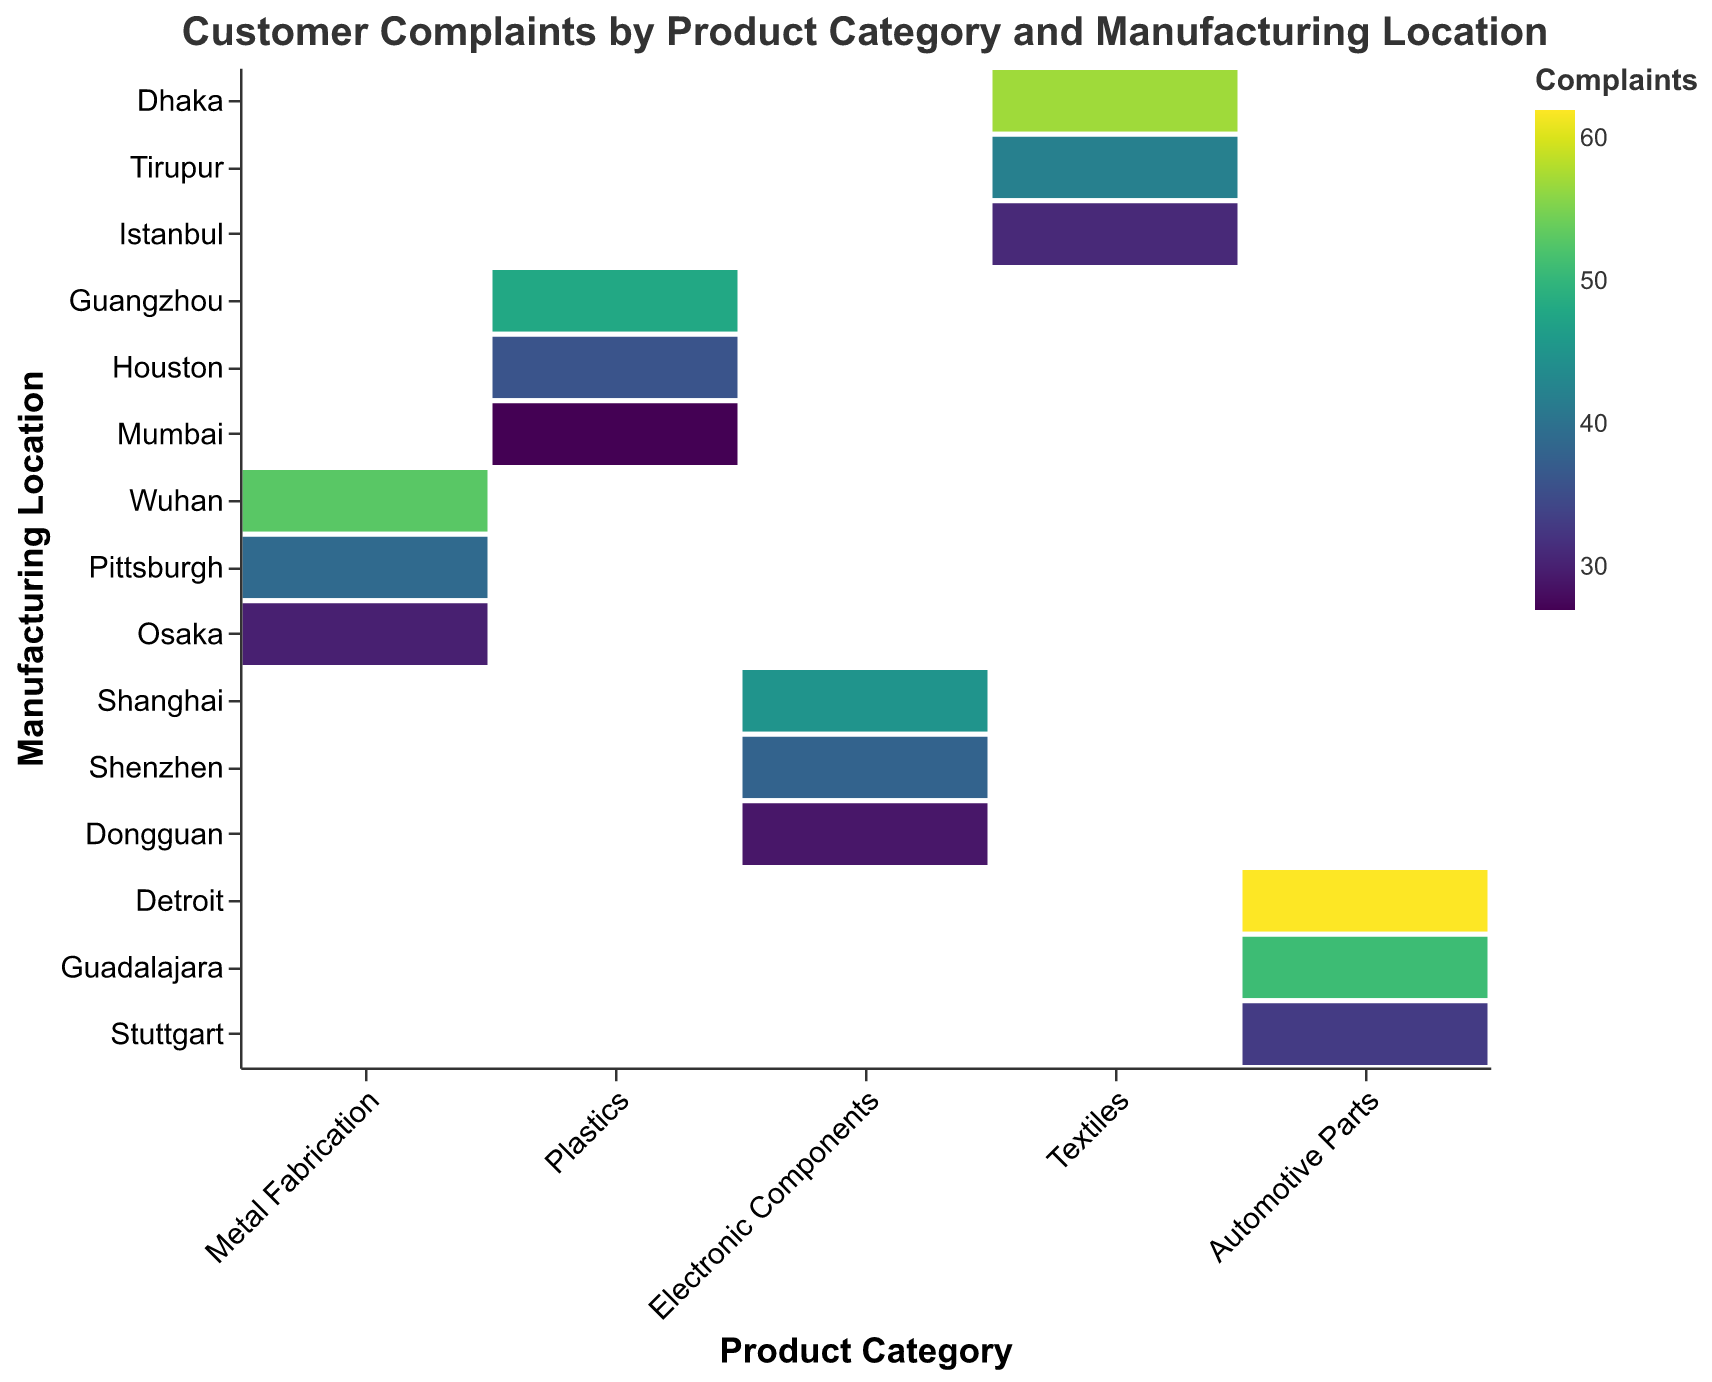What is the title of the figure? The title of a figure is typically displayed at the top and summarizes the content of the visualization. In this case, it states the focus of the plot, which is the relationship between customer complaints, product category, and manufacturing location.
Answer: Customer Complaints by Product Category and Manufacturing Location Which manufacturing location has the highest number of complaints for Automotive Parts? To find this, locate the 'Automotive Parts' category along the x-axis and look at the complaints (color intensity) for each location along the y-axis. Detroit has the most intense color.
Answer: Detroit How many manufacturing locations are shown in the plot? Count the unique entries along the y-axis, each representing a manufacturing location.
Answer: 15 Which product category has the fewest total customer complaints? Summing the complaint numbers for each location in each category, determine that 'Electronic Components' has the fewest complaints.
Answer: Electronic Components Compare the number of complaints for Textiles in Dhaka and Tirupur. Which location has more complaints? Locate 'Textiles' on the x-axis and compare the two corresponding locations 'Dhaka' and 'Tirupur' on the y-axis. Dhaka has 57 complaints, and Tirupur has 42.
Answer: Dhaka What is the average number of complaints for Plastics across all manufacturing locations? Sum the complaints for 'Plastics' and divide by the number of locations: (48 + 36 + 27) / 3.
Answer: 37 Which manufacturing location has the highest total number of complaints across all product categories? Sum the complaints for each location across all categories and find the maximum. Detroit has the highest total.
Answer: Detroit Which product category has the most significant spread in complaints across its manufacturing locations? Determine each category's spread by subtracting the minimum number of complaints from the maximum within the category. 'Automotive Parts' shows the greatest variation (62 - 33 = 29).
Answer: Automotive Parts Which product category at the 'Guangzhou' location has the highest complaints? Find the intersection of 'Guangzhou' (y-axis) with each product category (x-axis) and determine that 'Plastics' has the highest complaints.
Answer: Plastics What is the color scheme used to represent the number of complaints? The plot uses a color gradient from a darker hue to a lighter hue, indicating lower to higher numbers of complaints respectively. The color scheme is 'viridis.'
Answer: Viridis 